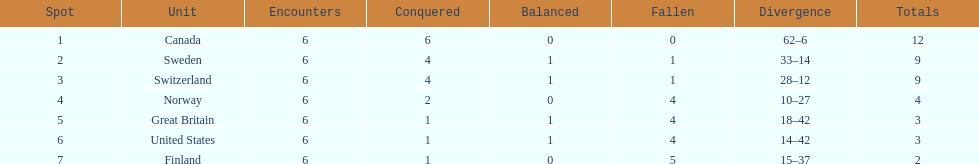What are the names of the countries? Canada, Sweden, Switzerland, Norway, Great Britain, United States, Finland. How many wins did switzerland have? 4. How many wins did great britain have? 1. Which country had more wins, great britain or switzerland? Switzerland. 